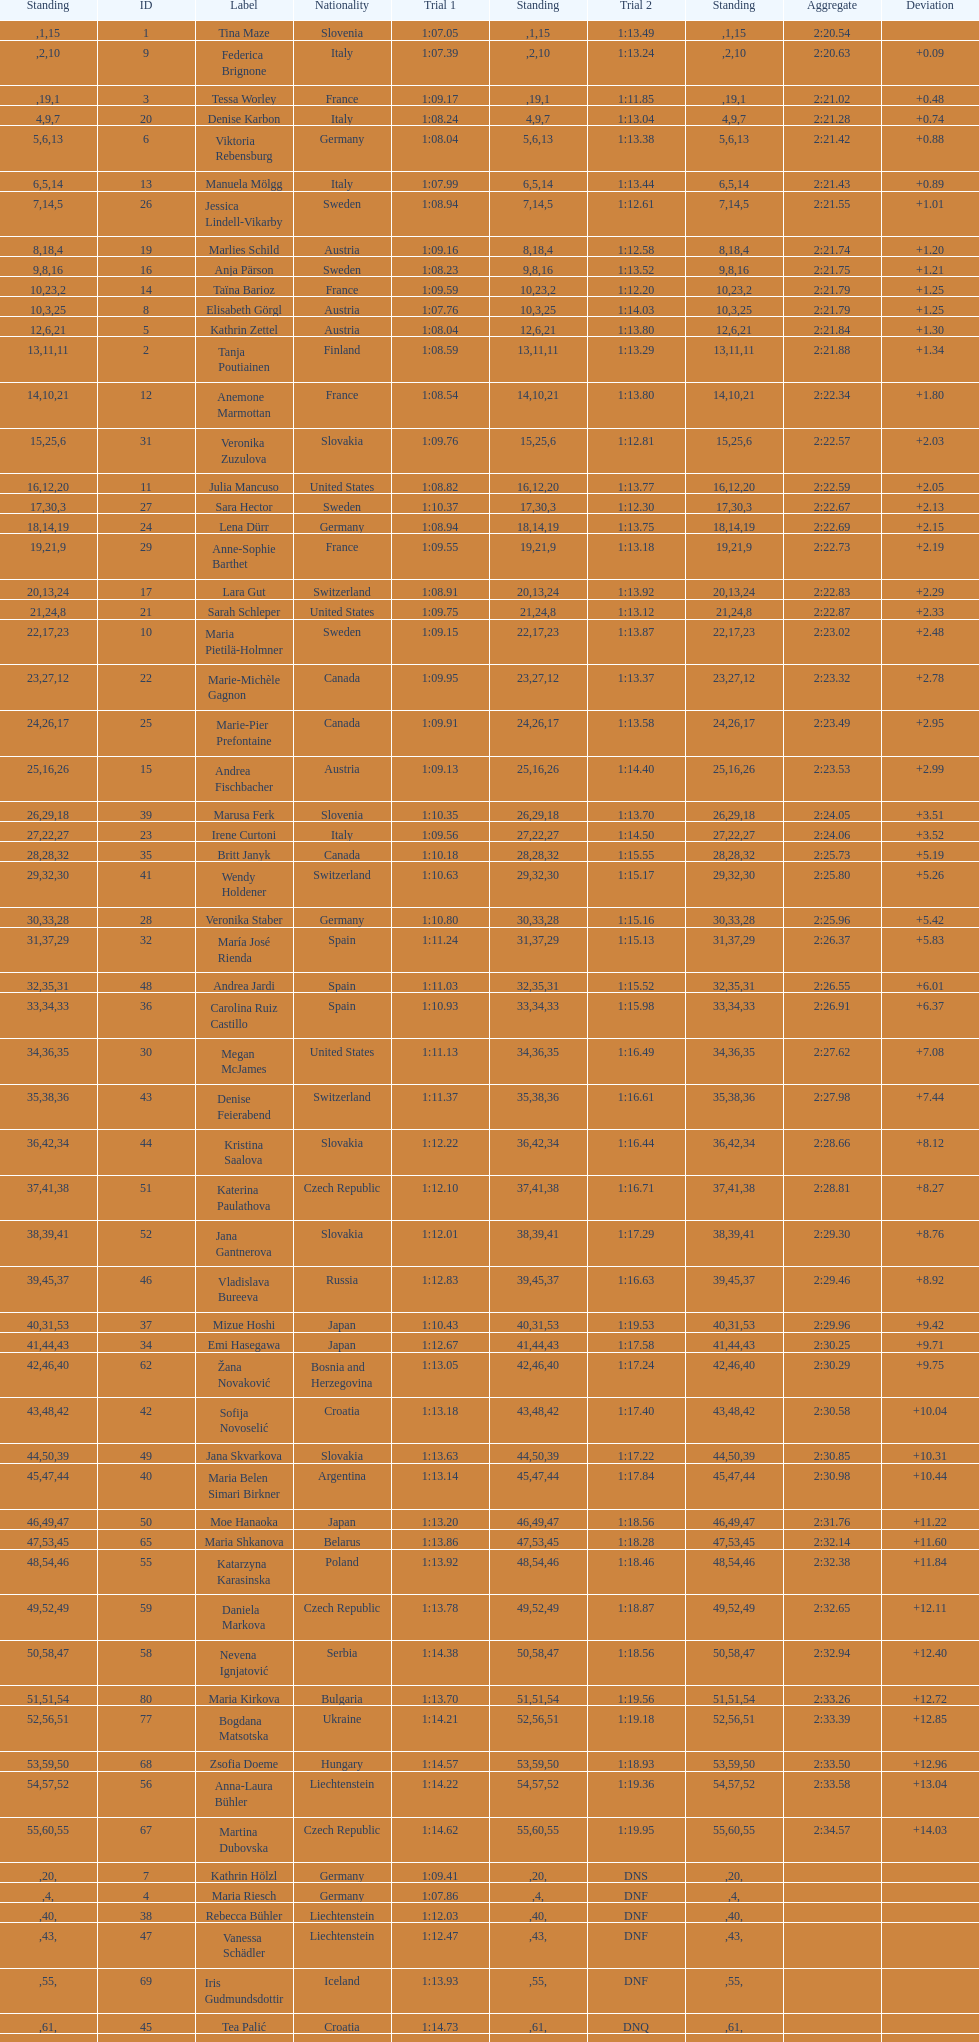What is the last nation to be ranked? Czech Republic. 